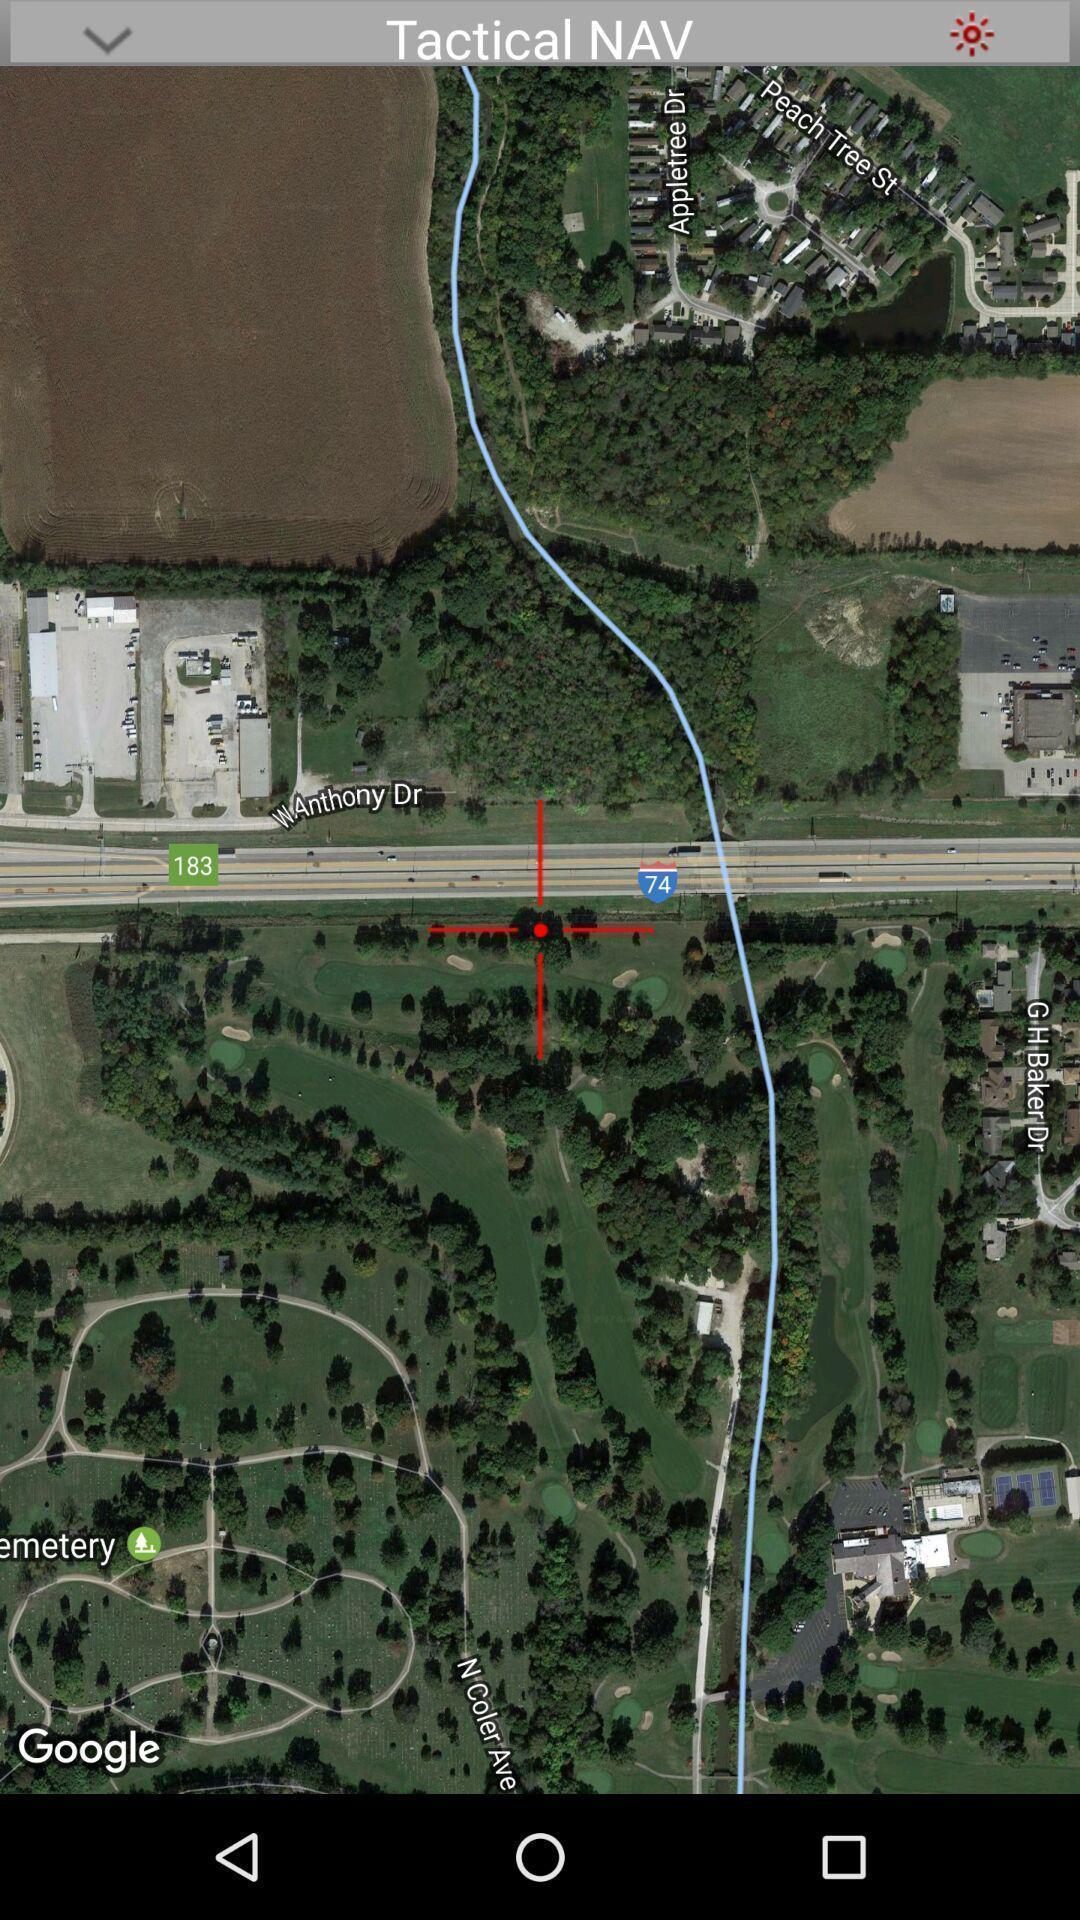Explain the elements present in this screenshot. Screen showing map view of route. 